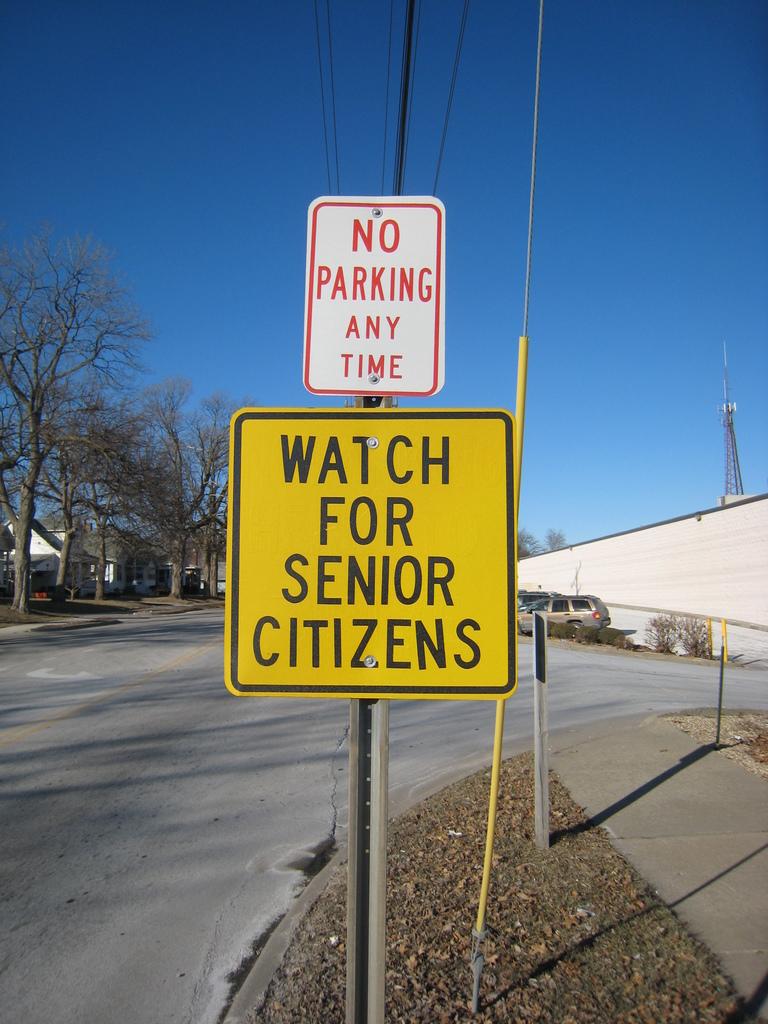What should you watch out for?
Provide a short and direct response. Senior citizens. What should you not do here anytime?
Give a very brief answer. Parking. 